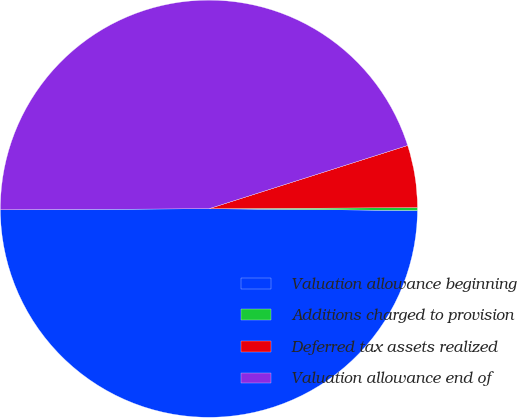Convert chart to OTSL. <chart><loc_0><loc_0><loc_500><loc_500><pie_chart><fcel>Valuation allowance beginning<fcel>Additions charged to provision<fcel>Deferred tax assets realized<fcel>Valuation allowance end of<nl><fcel>49.78%<fcel>0.22%<fcel>4.82%<fcel>45.18%<nl></chart> 